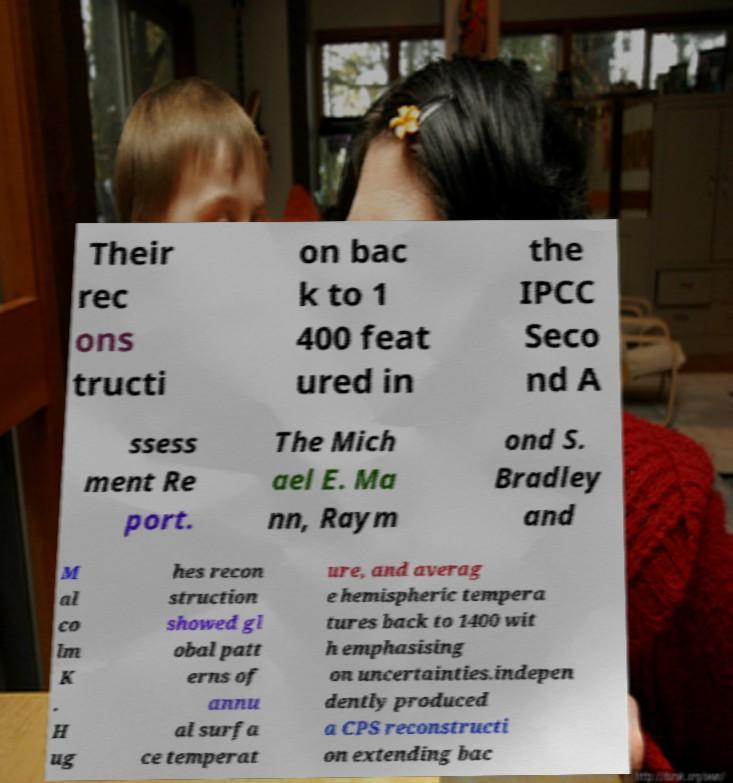For documentation purposes, I need the text within this image transcribed. Could you provide that? Their rec ons tructi on bac k to 1 400 feat ured in the IPCC Seco nd A ssess ment Re port. The Mich ael E. Ma nn, Raym ond S. Bradley and M al co lm K . H ug hes recon struction showed gl obal patt erns of annu al surfa ce temperat ure, and averag e hemispheric tempera tures back to 1400 wit h emphasising on uncertainties.indepen dently produced a CPS reconstructi on extending bac 